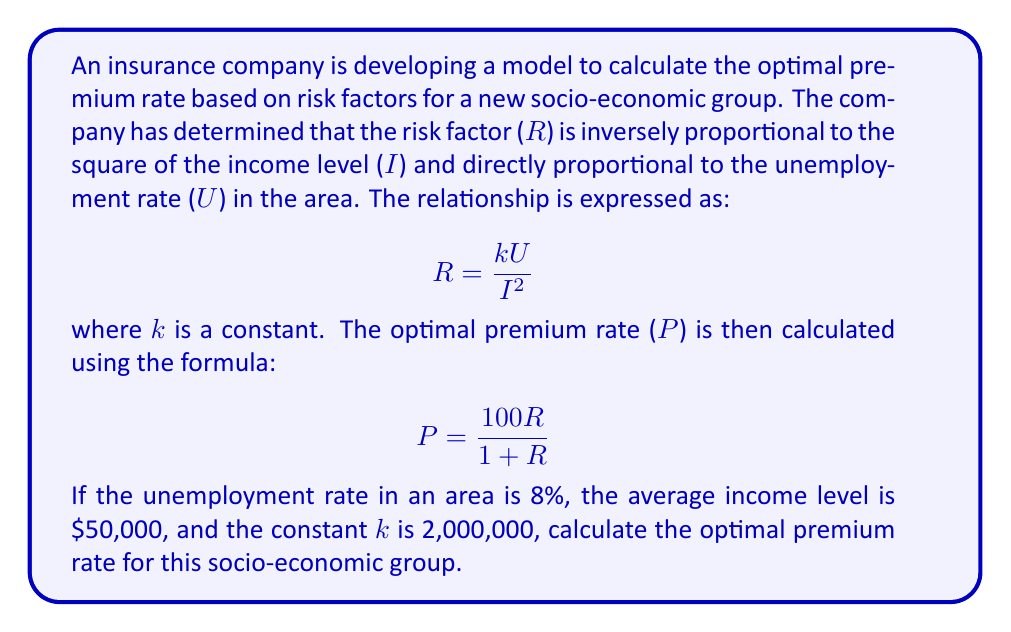Provide a solution to this math problem. Let's approach this step-by-step:

1) First, we need to calculate the risk factor (R) using the given formula:

   $$R = \frac{kU}{I^2}$$

2) We're given the following values:
   k = 2,000,000
   U = 8% = 0.08
   I = $50,000 = 50,000

3) Let's substitute these values into the formula:

   $$R = \frac{2,000,000 \times 0.08}{50,000^2}$$

4) Simplify:
   $$R = \frac{160,000}{2,500,000,000} = 0.000064$$

5) Now that we have R, we can calculate the optimal premium rate (P) using the formula:

   $$P = \frac{100R}{1 + R}$$

6) Substitute the value of R:

   $$P = \frac{100 \times 0.000064}{1 + 0.000064}$$

7) Simplify:
   $$P = \frac{0.0064}{1.000064} \approx 0.006399$$

8) Convert to a percentage:
   0.006399 × 100 ≈ 0.6399%

Therefore, the optimal premium rate for this socio-economic group is approximately 0.6399% of the insured value.
Answer: 0.6399% 